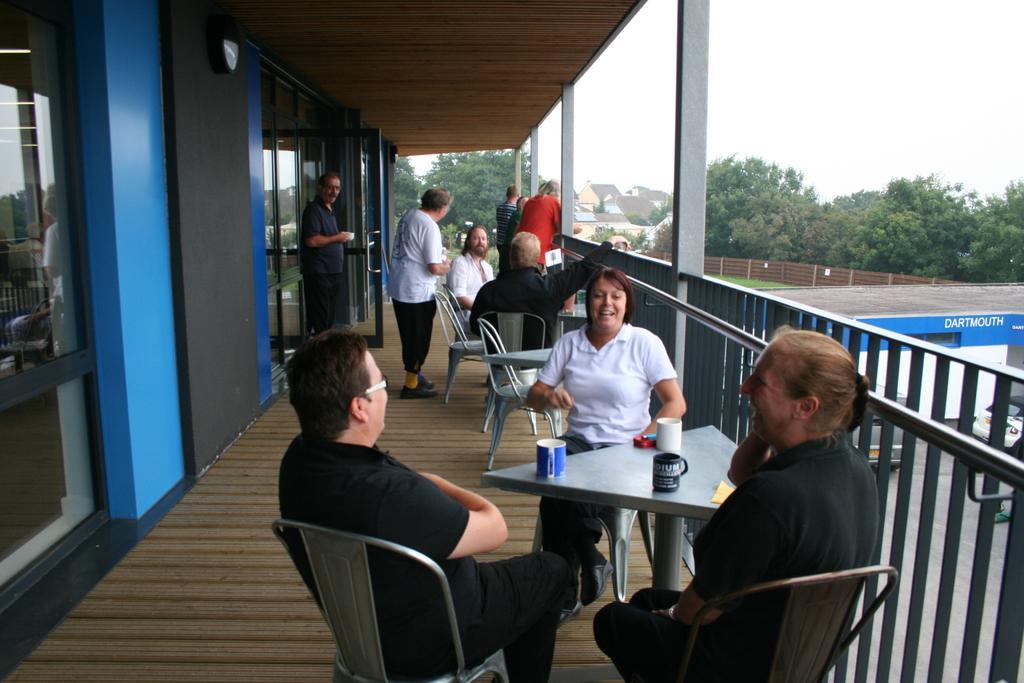In one or two sentences, can you explain what this image depicts? In this image we can see few people are sitting around the table. There are glass doors, trees, fence and buildings 